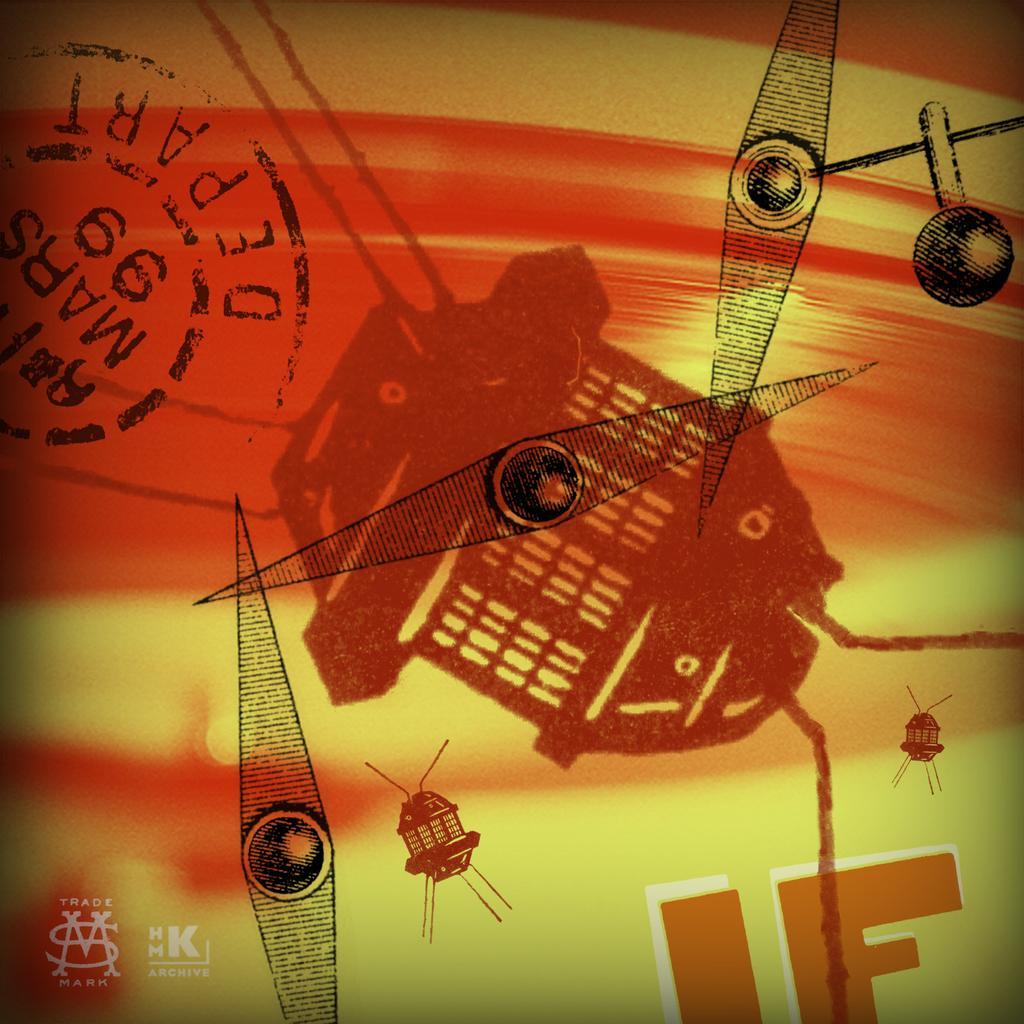Can you describe this image briefly? In this picture we can see the stamp seal in the top left. We can see the logo, some text and a few objects. 